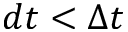Convert formula to latex. <formula><loc_0><loc_0><loc_500><loc_500>d t < \Delta t</formula> 